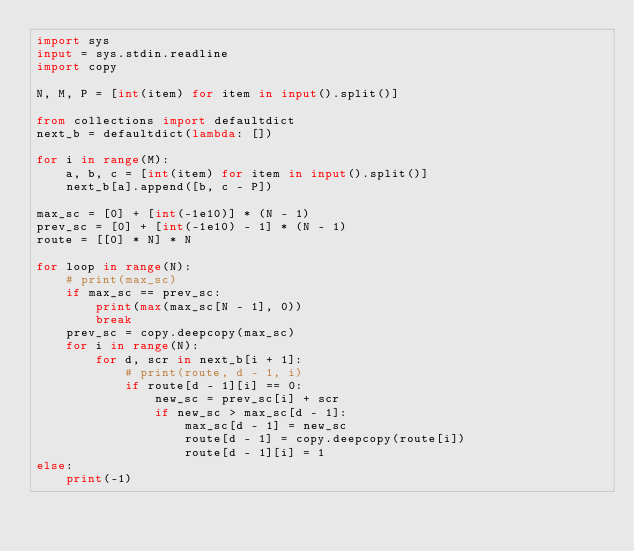<code> <loc_0><loc_0><loc_500><loc_500><_Python_>import sys
input = sys.stdin.readline
import copy

N, M, P = [int(item) for item in input().split()]

from collections import defaultdict
next_b = defaultdict(lambda: [])

for i in range(M):
    a, b, c = [int(item) for item in input().split()]
    next_b[a].append([b, c - P])

max_sc = [0] + [int(-1e10)] * (N - 1)
prev_sc = [0] + [int(-1e10) - 1] * (N - 1)
route = [[0] * N] * N

for loop in range(N):
    # print(max_sc)
    if max_sc == prev_sc:
        print(max(max_sc[N - 1], 0))
        break
    prev_sc = copy.deepcopy(max_sc)
    for i in range(N):
        for d, scr in next_b[i + 1]:
            # print(route, d - 1, i)
            if route[d - 1][i] == 0:
                new_sc = prev_sc[i] + scr
                if new_sc > max_sc[d - 1]:
                    max_sc[d - 1] = new_sc
                    route[d - 1] = copy.deepcopy(route[i])
                    route[d - 1][i] = 1
else:
    print(-1)
</code> 